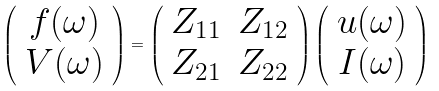Convert formula to latex. <formula><loc_0><loc_0><loc_500><loc_500>\left ( \begin{array} { c } f ( \omega ) \\ V ( \omega ) \end{array} \right ) = \left ( \begin{array} { c c } Z _ { 1 1 } & Z _ { 1 2 } \\ Z _ { 2 1 } & Z _ { 2 2 } \end{array} \right ) \left ( \begin{array} { c } u ( \omega ) \\ I ( \omega ) \end{array} \right )</formula> 